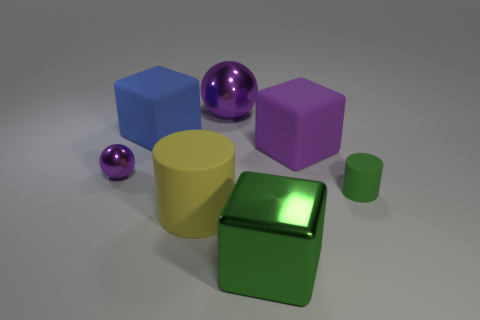There is a matte thing that is the same color as the tiny ball; what shape is it?
Your response must be concise. Cube. There is a purple rubber block; what number of large green blocks are right of it?
Keep it short and to the point. 0. Does the yellow thing have the same shape as the small metal thing?
Keep it short and to the point. No. What number of small objects are both in front of the small metal object and on the left side of the yellow matte cylinder?
Make the answer very short. 0. What number of objects are small shiny balls or purple objects that are behind the big blue object?
Your answer should be compact. 2. Is the number of purple metal balls greater than the number of red spheres?
Make the answer very short. Yes. There is a large metal thing that is in front of the green rubber cylinder; what shape is it?
Give a very brief answer. Cube. How many large cyan metallic objects are the same shape as the large purple matte thing?
Give a very brief answer. 0. How big is the ball that is on the right side of the matte thing that is to the left of the big yellow cylinder?
Provide a succinct answer. Large. What number of cyan things are large blocks or matte objects?
Your answer should be compact. 0. 